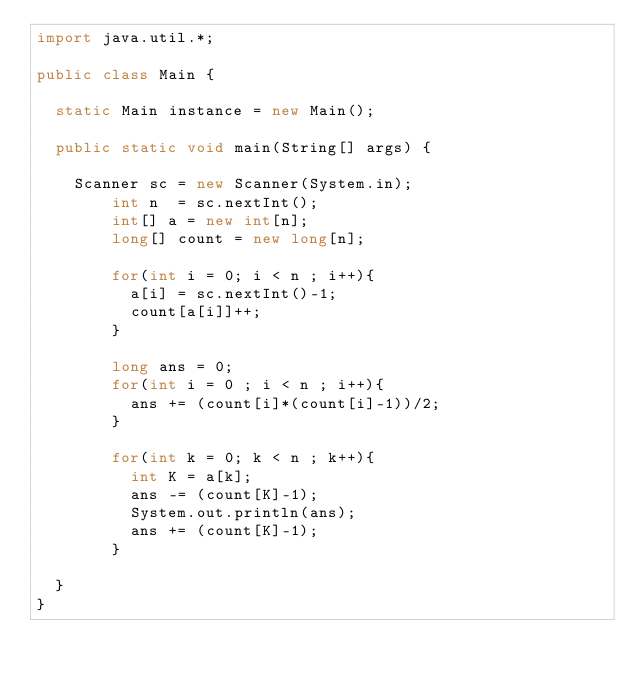<code> <loc_0><loc_0><loc_500><loc_500><_Java_>import java.util.*;
 
public class Main {
 
	static Main instance = new Main();
 
	public static void main(String[] args) {
 
		Scanner sc = new Scanner(System.in);
        int n  = sc.nextInt();
        int[] a = new int[n];
        long[] count = new long[n];
      
        for(int i = 0; i < n ; i++){
          a[i] = sc.nextInt()-1;
          count[a[i]]++;
        }
        
        long ans = 0;
        for(int i = 0 ; i < n ; i++){
          ans += (count[i]*(count[i]-1))/2;
        }
        
        for(int k = 0; k < n ; k++){
          int K = a[k];
          ans -= (count[K]-1);
          System.out.println(ans);
          ans += (count[K]-1);
        }
      
	}
}</code> 